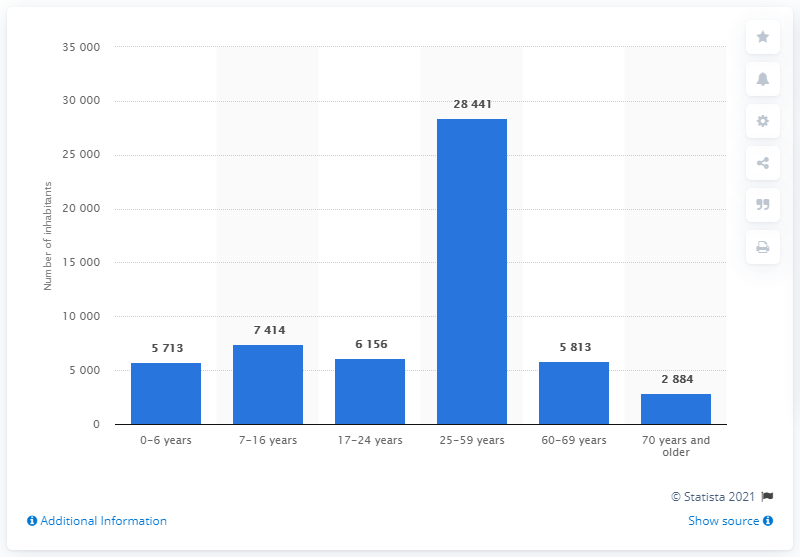List a handful of essential elements in this visual. As of January 1, 2021, there were approximately 28,441 people in Greenland who were between the ages of 25 and 59. In 2021, there were approximately 7,414 people between the ages of seven and 16 in Greenland. 